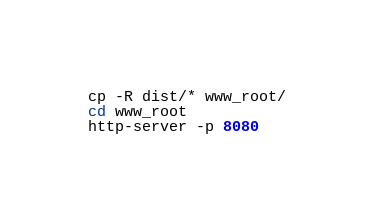<code> <loc_0><loc_0><loc_500><loc_500><_Bash_>cp -R dist/* www_root/
cd www_root
http-server -p 8080</code> 